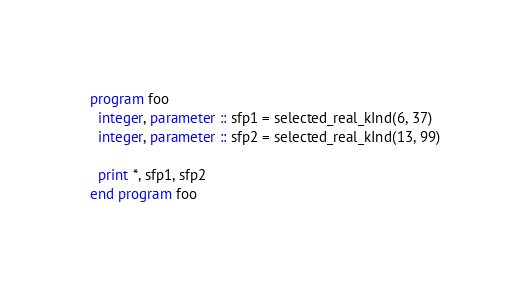Convert code to text. <code><loc_0><loc_0><loc_500><loc_500><_FORTRAN_>program foo
  integer, parameter :: sfp1 = selected_real_kInd(6, 37)
  integer, parameter :: sfp2 = selected_real_kInd(13, 99)

  print *, sfp1, sfp2
end program foo

</code> 